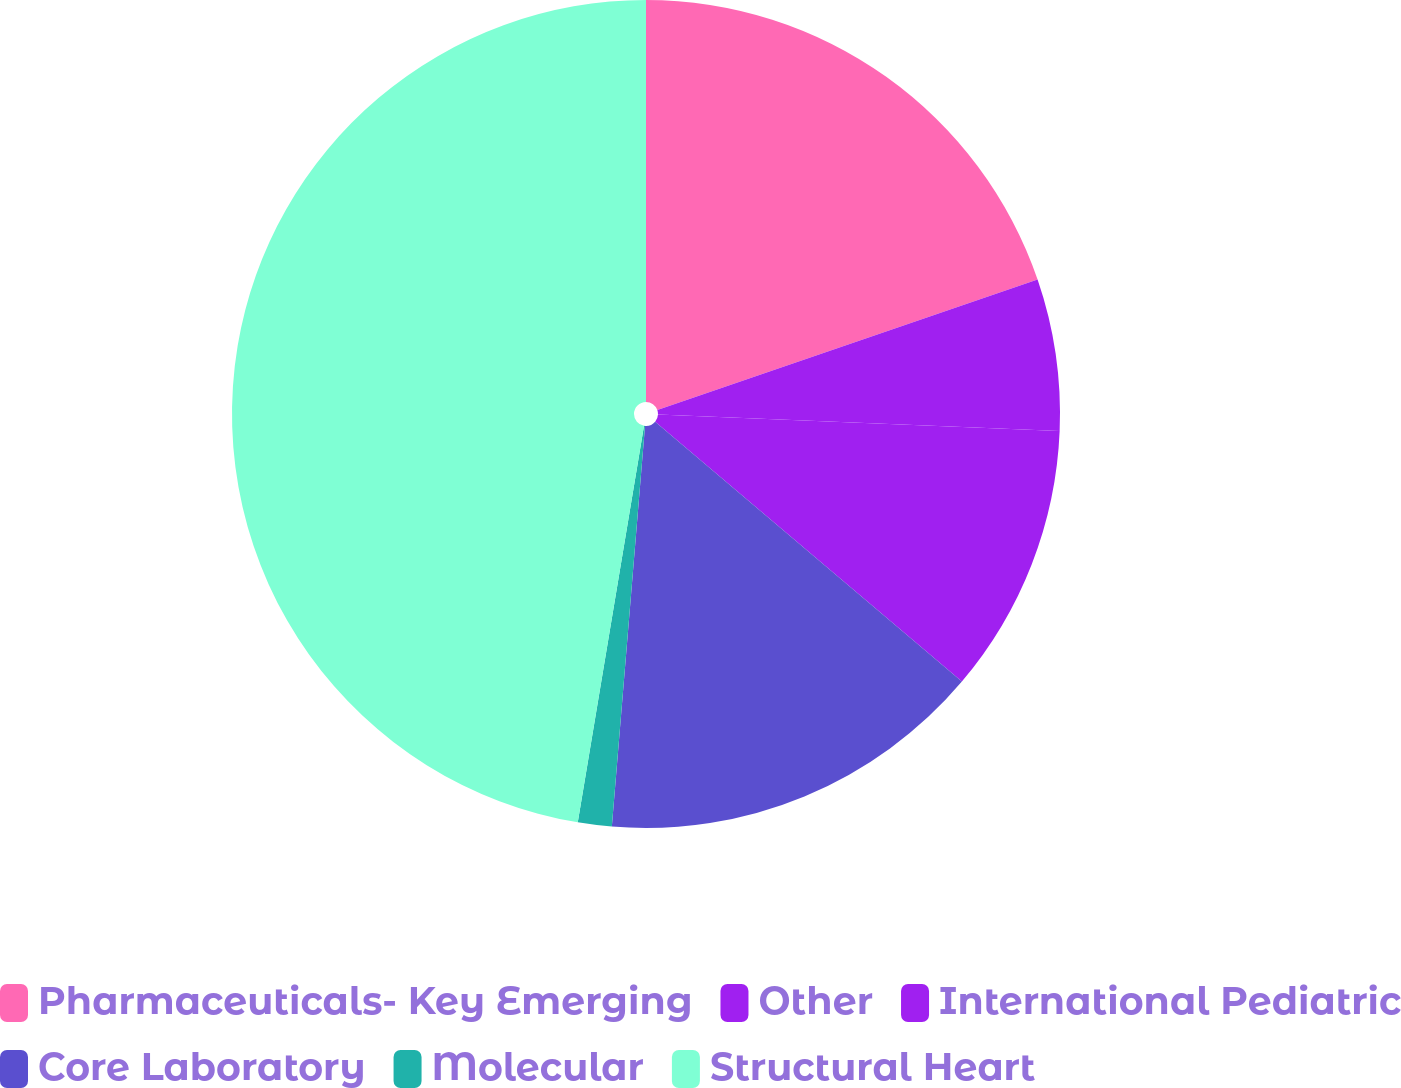Convert chart. <chart><loc_0><loc_0><loc_500><loc_500><pie_chart><fcel>Pharmaceuticals- Key Emerging<fcel>Other<fcel>International Pediatric<fcel>Core Laboratory<fcel>Molecular<fcel>Structural Heart<nl><fcel>19.74%<fcel>5.92%<fcel>10.53%<fcel>15.13%<fcel>1.32%<fcel>47.37%<nl></chart> 